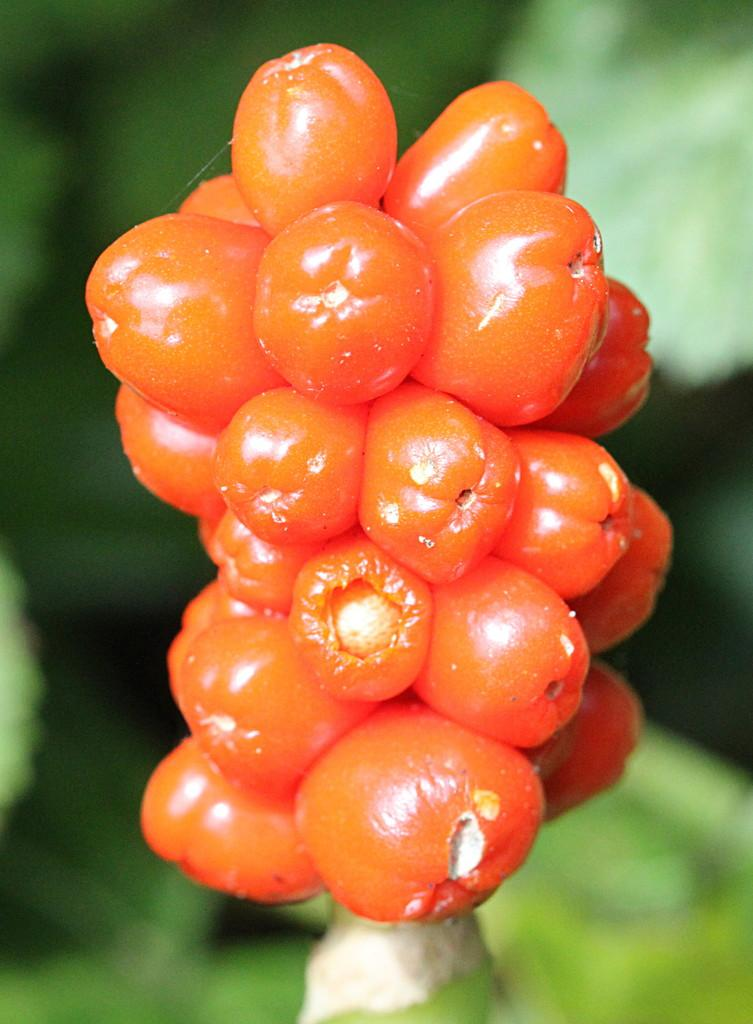What color are the fruits in the image? The fruits in the image are orange in color. What type of plant do the fruits belong to? The fruits belong to a plant. Can you describe the background of the image? The background of the image is blurred. How many feet are visible in the image? There are no feet visible in the image. What trick is being performed with the fruits in the image? There is no trick being performed with the fruits in the image; they are simply depicted as part of the plant. 